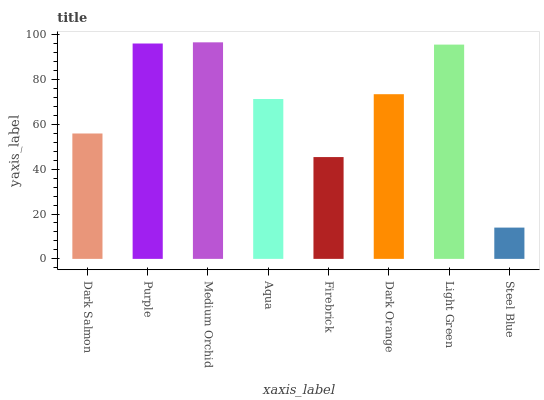Is Purple the minimum?
Answer yes or no. No. Is Purple the maximum?
Answer yes or no. No. Is Purple greater than Dark Salmon?
Answer yes or no. Yes. Is Dark Salmon less than Purple?
Answer yes or no. Yes. Is Dark Salmon greater than Purple?
Answer yes or no. No. Is Purple less than Dark Salmon?
Answer yes or no. No. Is Dark Orange the high median?
Answer yes or no. Yes. Is Aqua the low median?
Answer yes or no. Yes. Is Medium Orchid the high median?
Answer yes or no. No. Is Firebrick the low median?
Answer yes or no. No. 